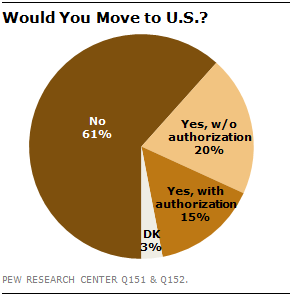Give some essential details in this illustration. The percentage of respondents who would move to the United States with authorization is 15%. Add all the segments with values below 30, then subtract the largest segment's value. The result will be 23. 